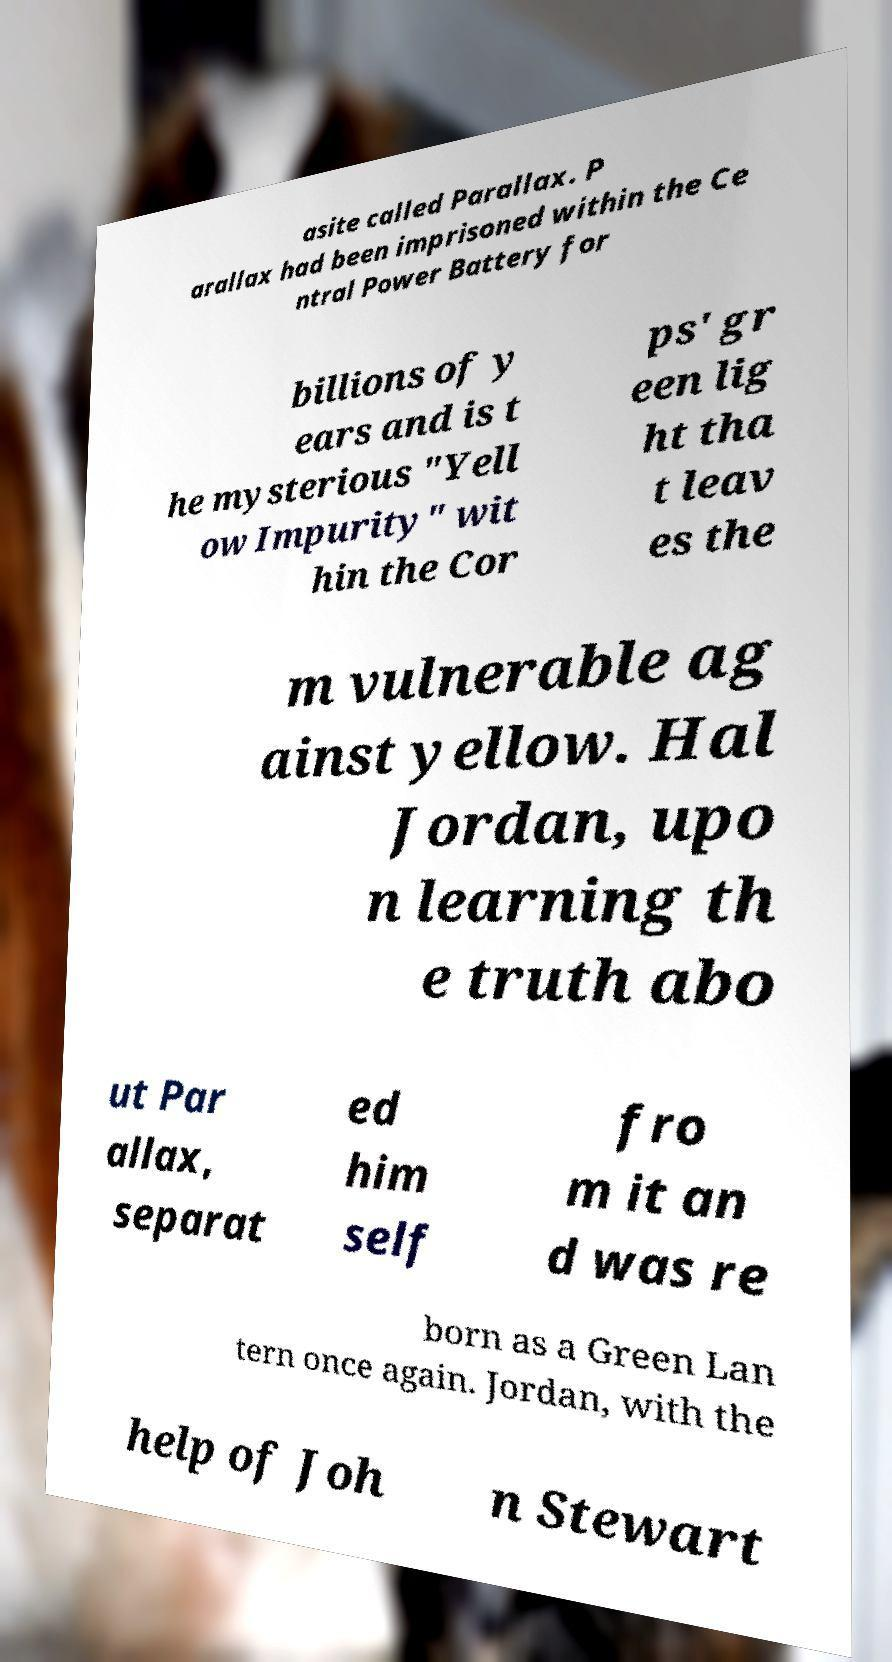For documentation purposes, I need the text within this image transcribed. Could you provide that? asite called Parallax. P arallax had been imprisoned within the Ce ntral Power Battery for billions of y ears and is t he mysterious "Yell ow Impurity" wit hin the Cor ps' gr een lig ht tha t leav es the m vulnerable ag ainst yellow. Hal Jordan, upo n learning th e truth abo ut Par allax, separat ed him self fro m it an d was re born as a Green Lan tern once again. Jordan, with the help of Joh n Stewart 